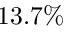<formula> <loc_0><loc_0><loc_500><loc_500>1 3 . 7 \%</formula> 